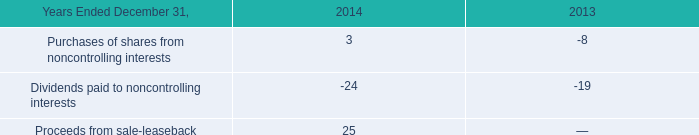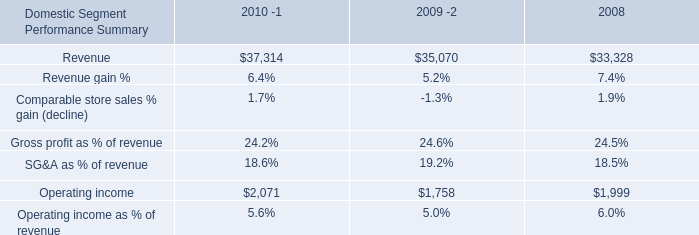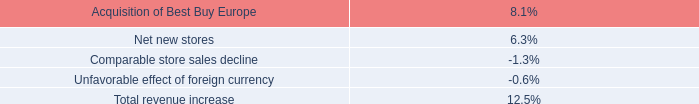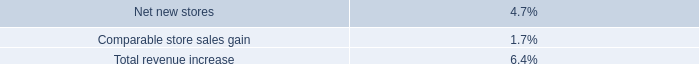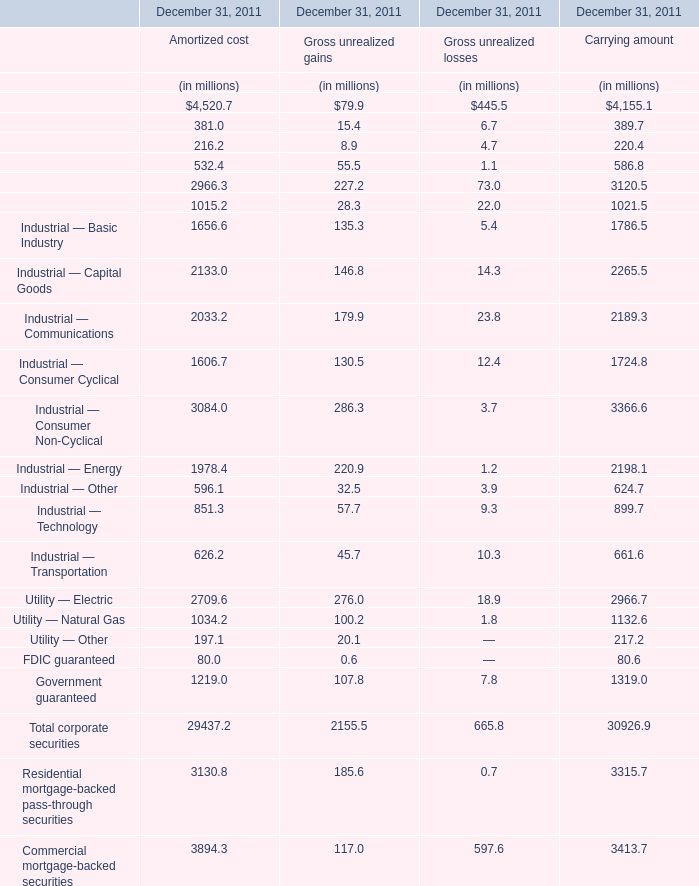what was the change in the prepaid pensions from 2014 to 2015 in millions 
Computations: (1033 - 933)
Answer: 100.0. 